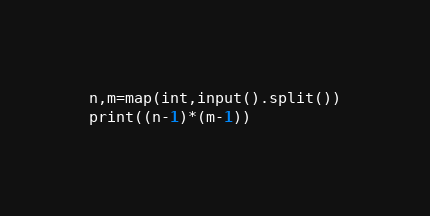<code> <loc_0><loc_0><loc_500><loc_500><_Python_>n,m=map(int,input().split())
print((n-1)*(m-1))</code> 